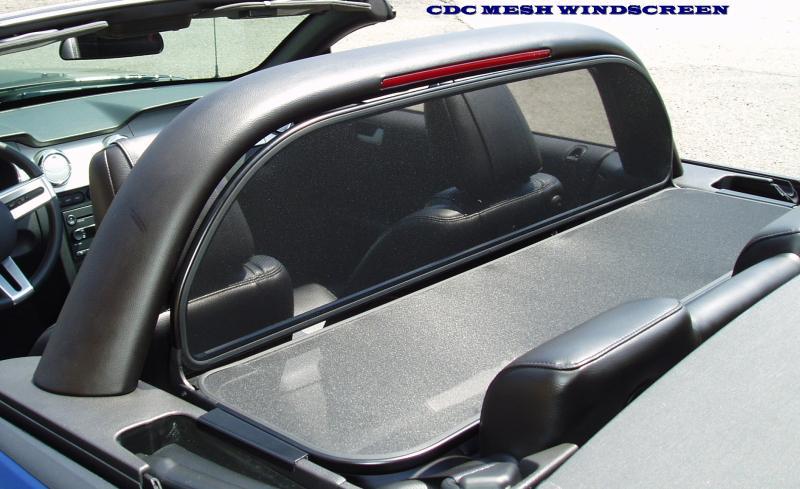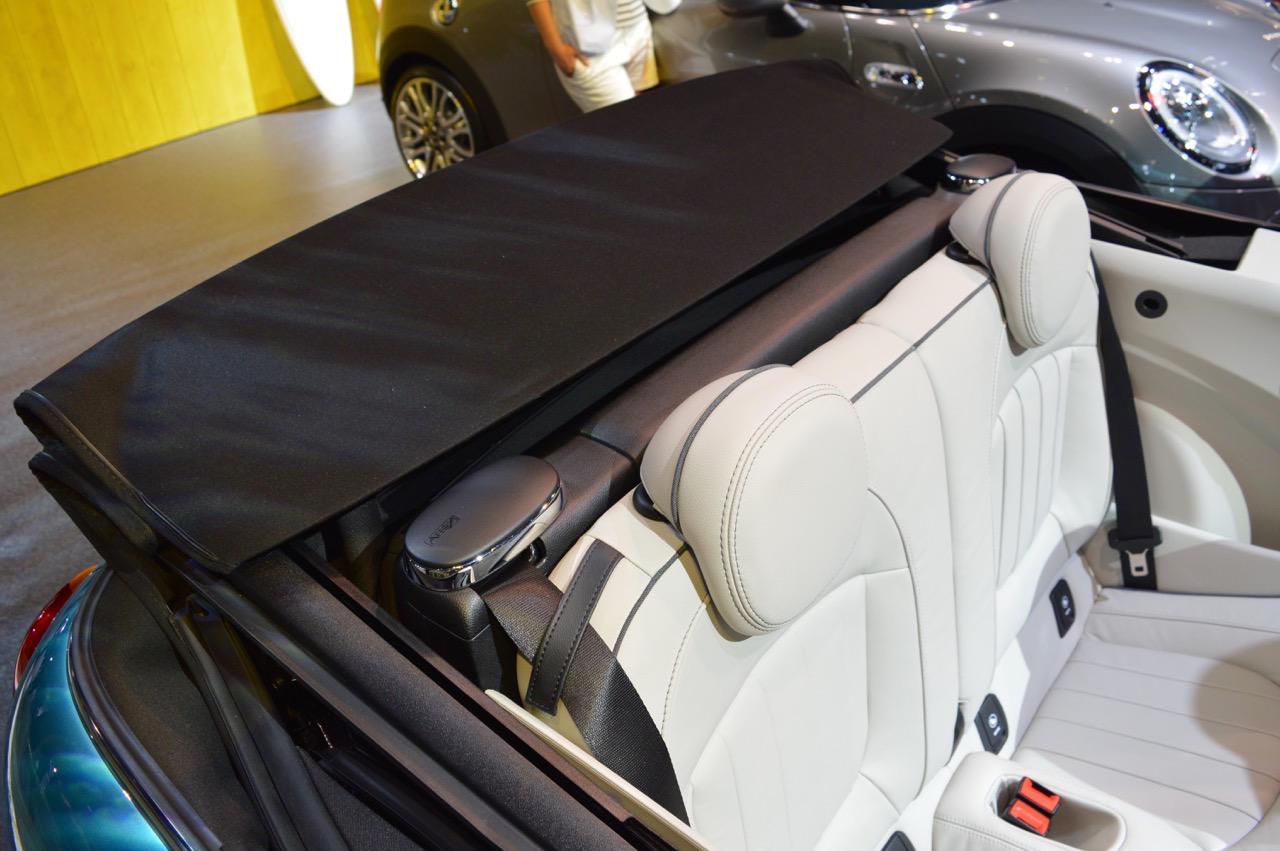The first image is the image on the left, the second image is the image on the right. Given the left and right images, does the statement "The black top of the car is rolled down in one of the images." hold true? Answer yes or no. Yes. The first image is the image on the left, the second image is the image on the right. Assess this claim about the two images: "One image shows white upholstered front seats and a darker steering wheel in a convertible car's interior, and the other image shows the folded soft top at the rear of the vehicle.". Correct or not? Answer yes or no. No. 